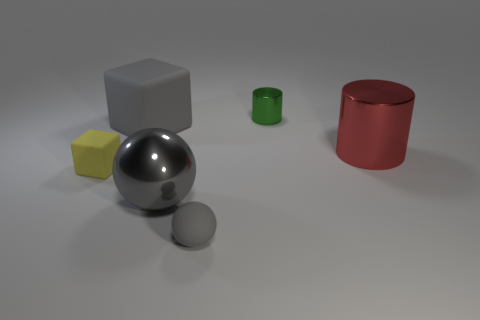What is the color of the large thing that is the same shape as the tiny green metal thing?
Keep it short and to the point. Red. There is a shiny thing to the left of the green metallic object; is its color the same as the rubber cube behind the red cylinder?
Offer a very short reply. Yes. Are there more small green cylinders that are to the left of the tiny metal cylinder than gray cubes?
Offer a very short reply. No. What number of objects are on the left side of the small cylinder and on the right side of the big sphere?
Make the answer very short. 1. Does the thing that is on the right side of the green metallic thing have the same material as the green object?
Ensure brevity in your answer.  Yes. There is a big metal thing that is to the left of the gray rubber object that is on the right side of the big object to the left of the gray metallic ball; what is its shape?
Keep it short and to the point. Sphere. Is the number of big red cylinders that are to the left of the metallic sphere the same as the number of small green metallic objects left of the tiny cube?
Provide a succinct answer. Yes. There is a ball that is the same size as the yellow object; what color is it?
Your answer should be compact. Gray. What number of big things are either shiny spheres or red shiny things?
Make the answer very short. 2. There is a tiny thing that is both to the right of the small yellow thing and in front of the red shiny cylinder; what is its material?
Offer a terse response. Rubber. 